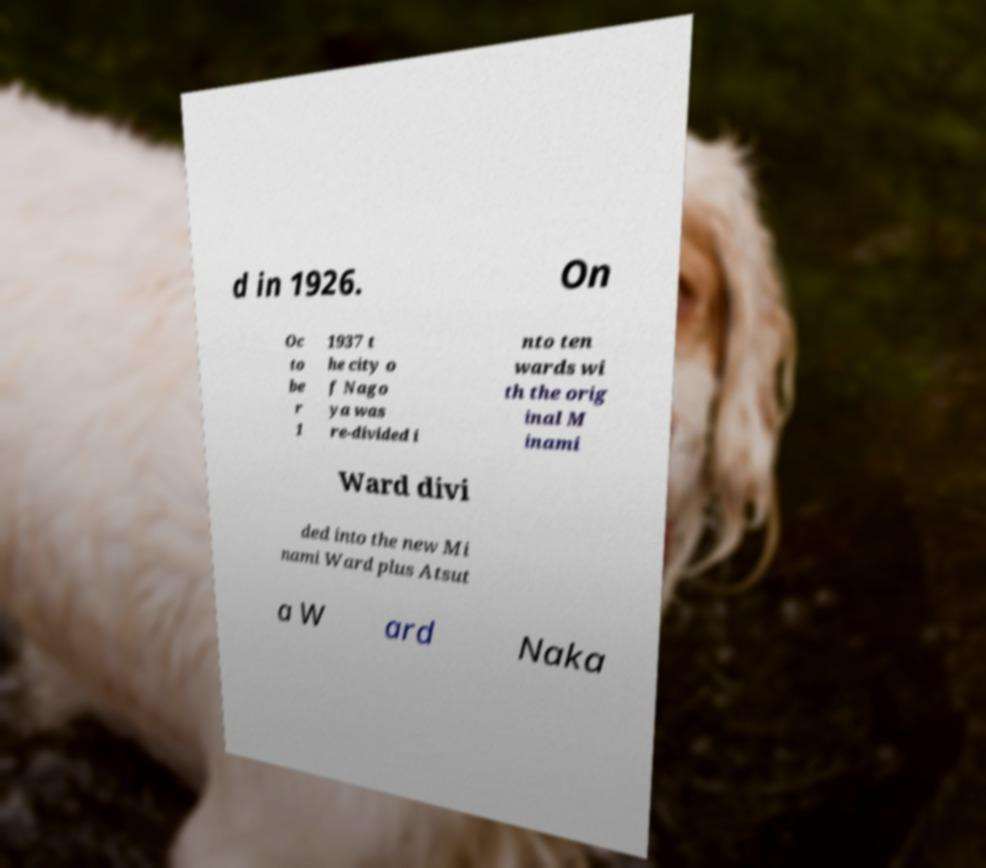Could you extract and type out the text from this image? d in 1926. On Oc to be r 1 1937 t he city o f Nago ya was re-divided i nto ten wards wi th the orig inal M inami Ward divi ded into the new Mi nami Ward plus Atsut a W ard Naka 